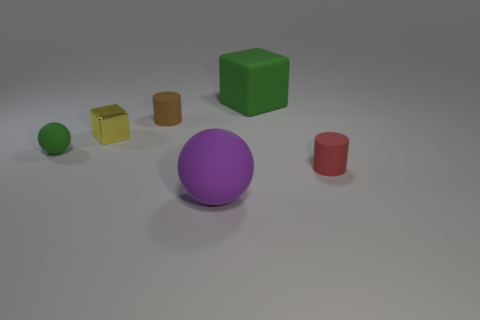Add 2 small red shiny blocks. How many objects exist? 8 Subtract all cylinders. How many objects are left? 4 Subtract 0 blue balls. How many objects are left? 6 Subtract all big cyan metallic cylinders. Subtract all large green matte objects. How many objects are left? 5 Add 1 cubes. How many cubes are left? 3 Add 5 small gray rubber cylinders. How many small gray rubber cylinders exist? 5 